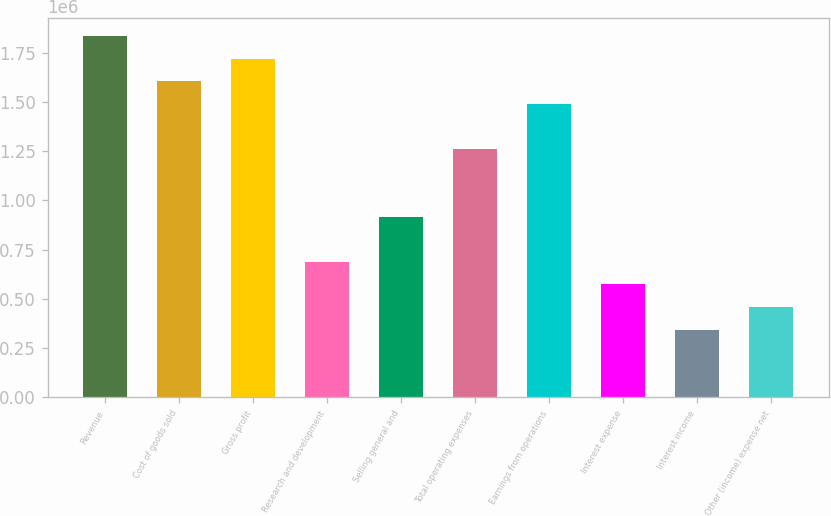Convert chart to OTSL. <chart><loc_0><loc_0><loc_500><loc_500><bar_chart><fcel>Revenue<fcel>Cost of goods sold<fcel>Gross profit<fcel>Research and development<fcel>Selling general and<fcel>Total operating expenses<fcel>Earnings from operations<fcel>Interest expense<fcel>Interest income<fcel>Other (income) expense net<nl><fcel>1.83534e+06<fcel>1.60592e+06<fcel>1.72063e+06<fcel>688253<fcel>917670<fcel>1.2618e+06<fcel>1.49121e+06<fcel>573544<fcel>344127<fcel>458836<nl></chart> 